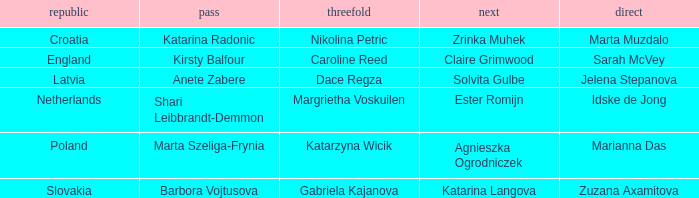What is the name of the third who has Barbora Vojtusova as Skip? Gabriela Kajanova. 